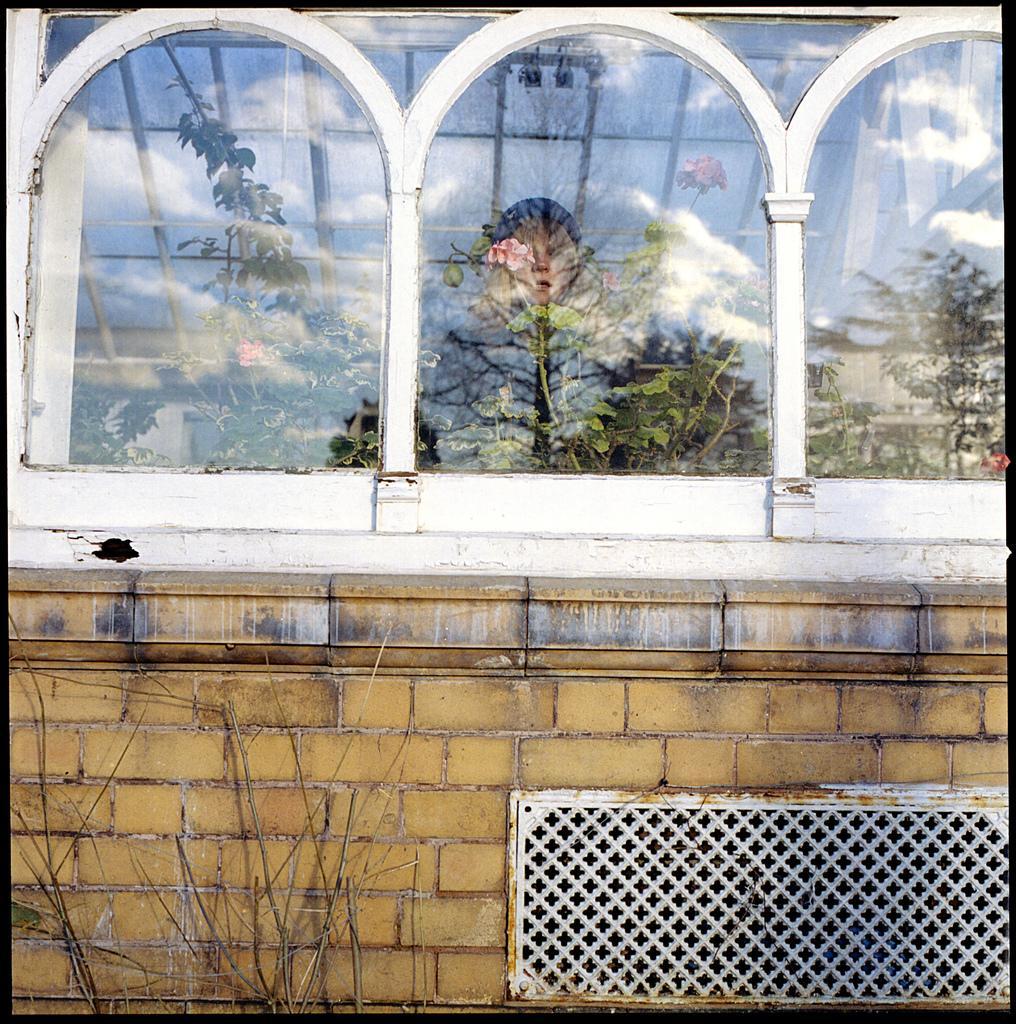Describe this image in one or two sentences. In this image I can see the building and there is a window to it. Inside the building I can see one person. I can also see the dried plant to the side. 